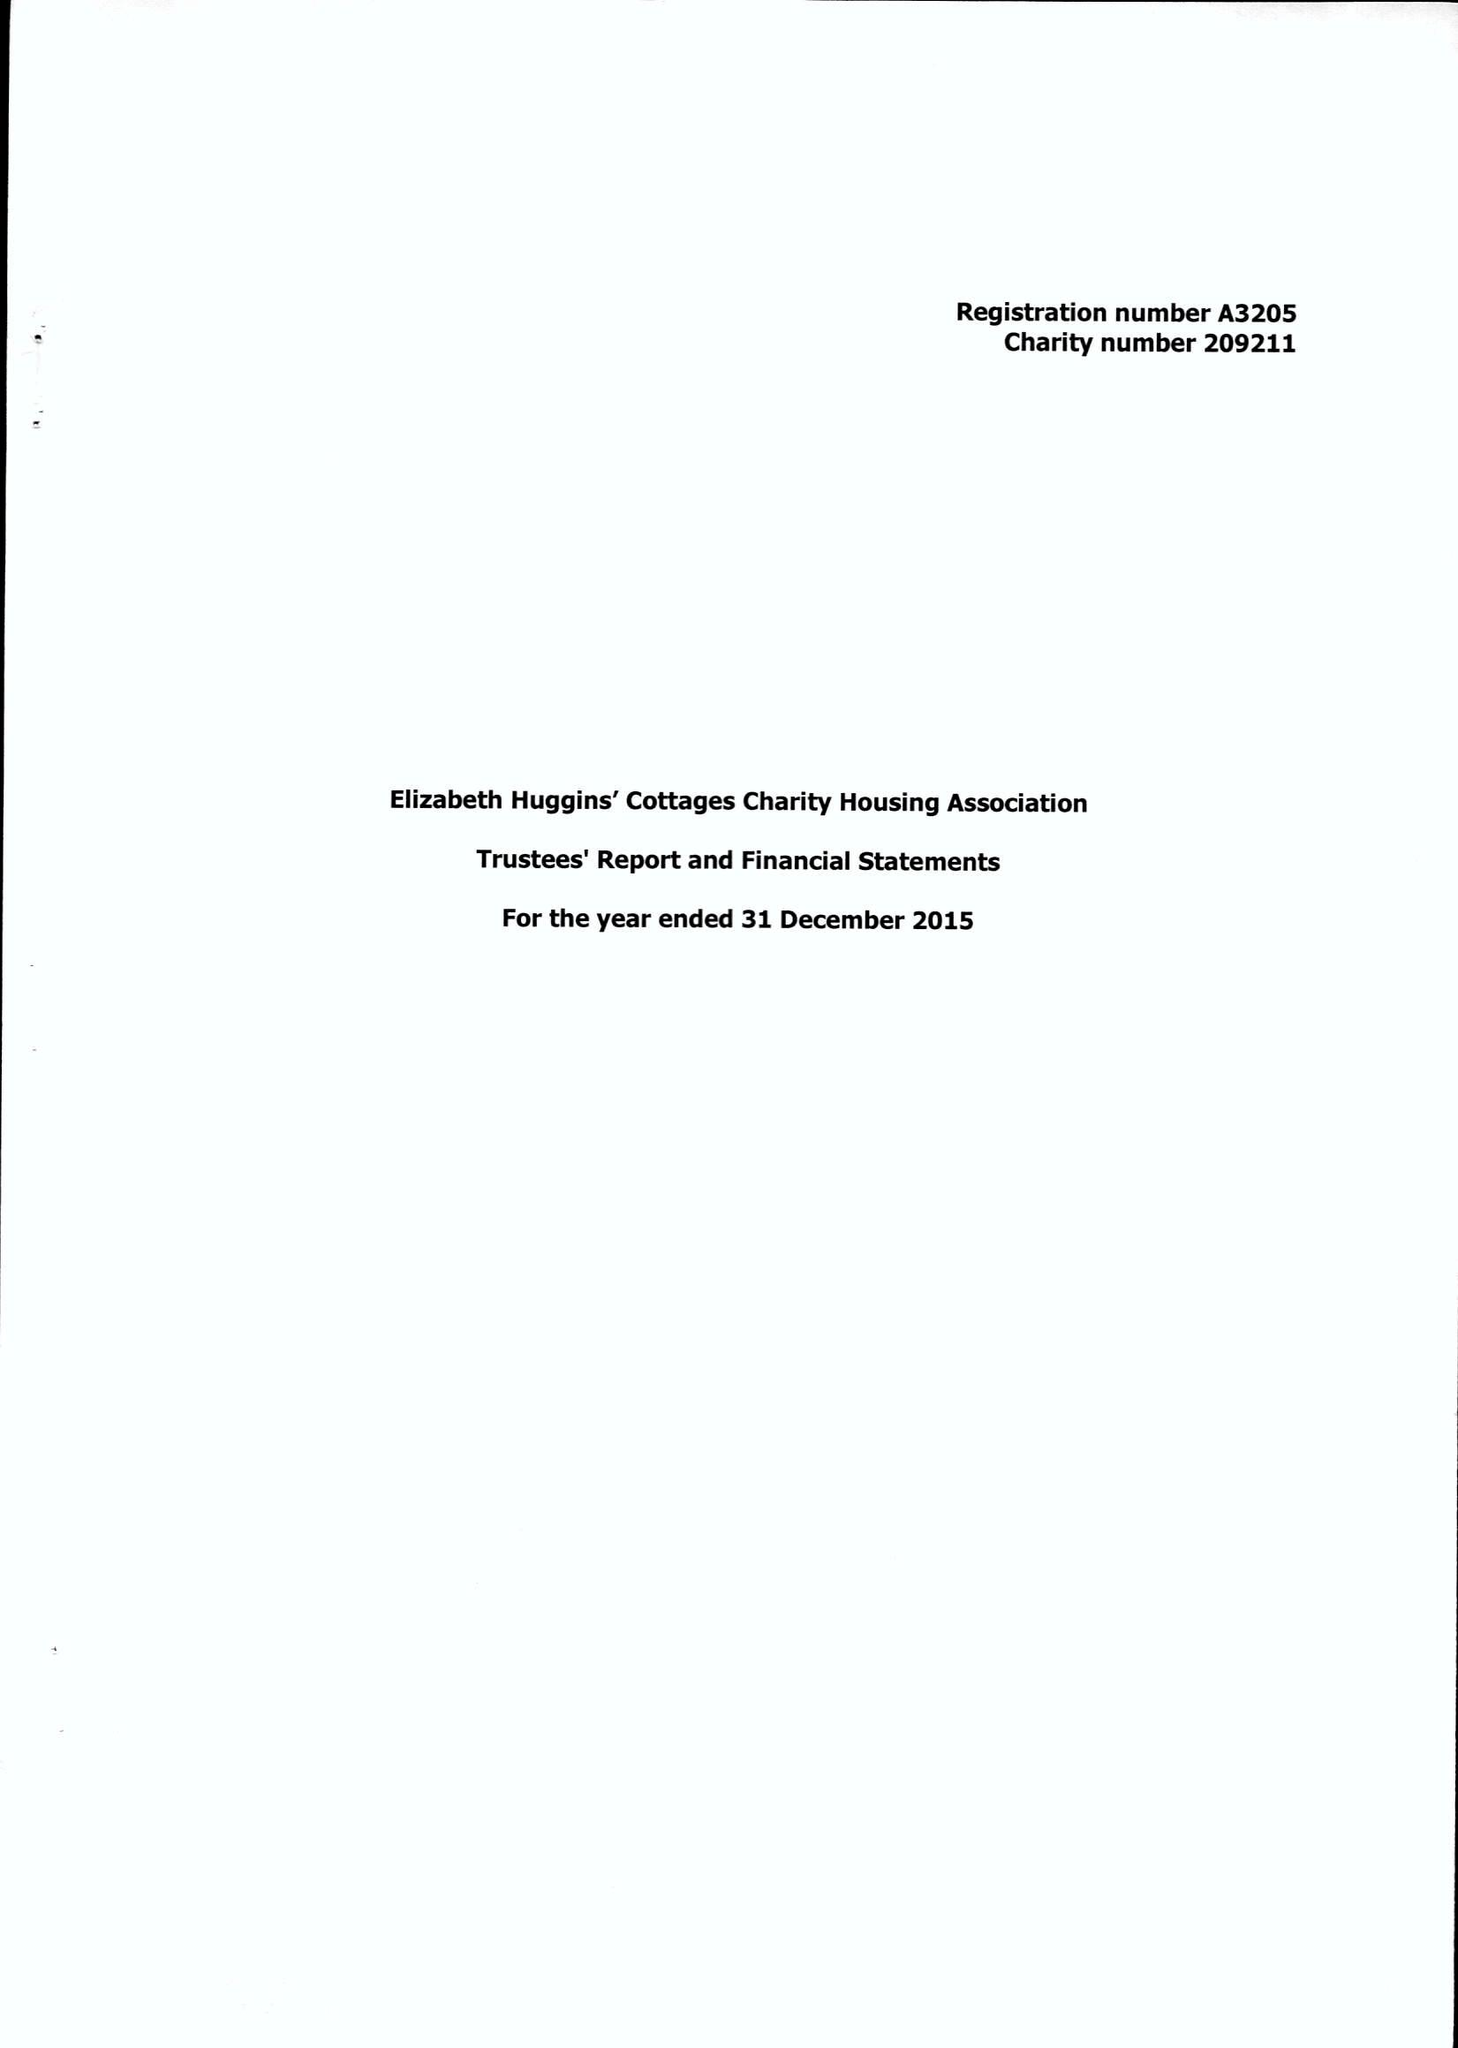What is the value for the charity_name?
Answer the question using a single word or phrase. Elizabeth Huggins Cottages Charity 